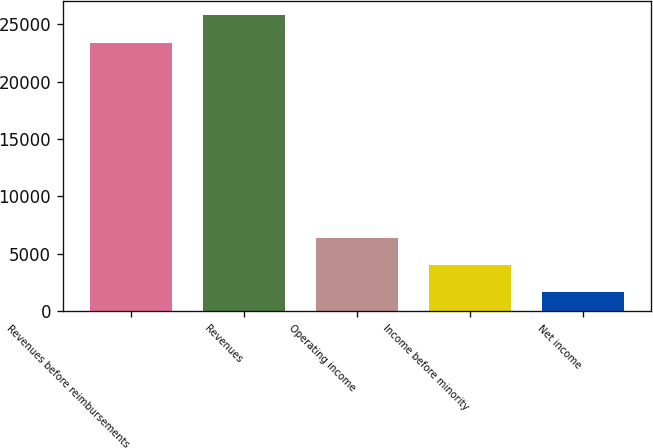Convert chart. <chart><loc_0><loc_0><loc_500><loc_500><bar_chart><fcel>Revenues before reimbursements<fcel>Revenues<fcel>Operating income<fcel>Income before minority<fcel>Net income<nl><fcel>23387<fcel>25749.2<fcel>6416.4<fcel>4054.2<fcel>1692<nl></chart> 